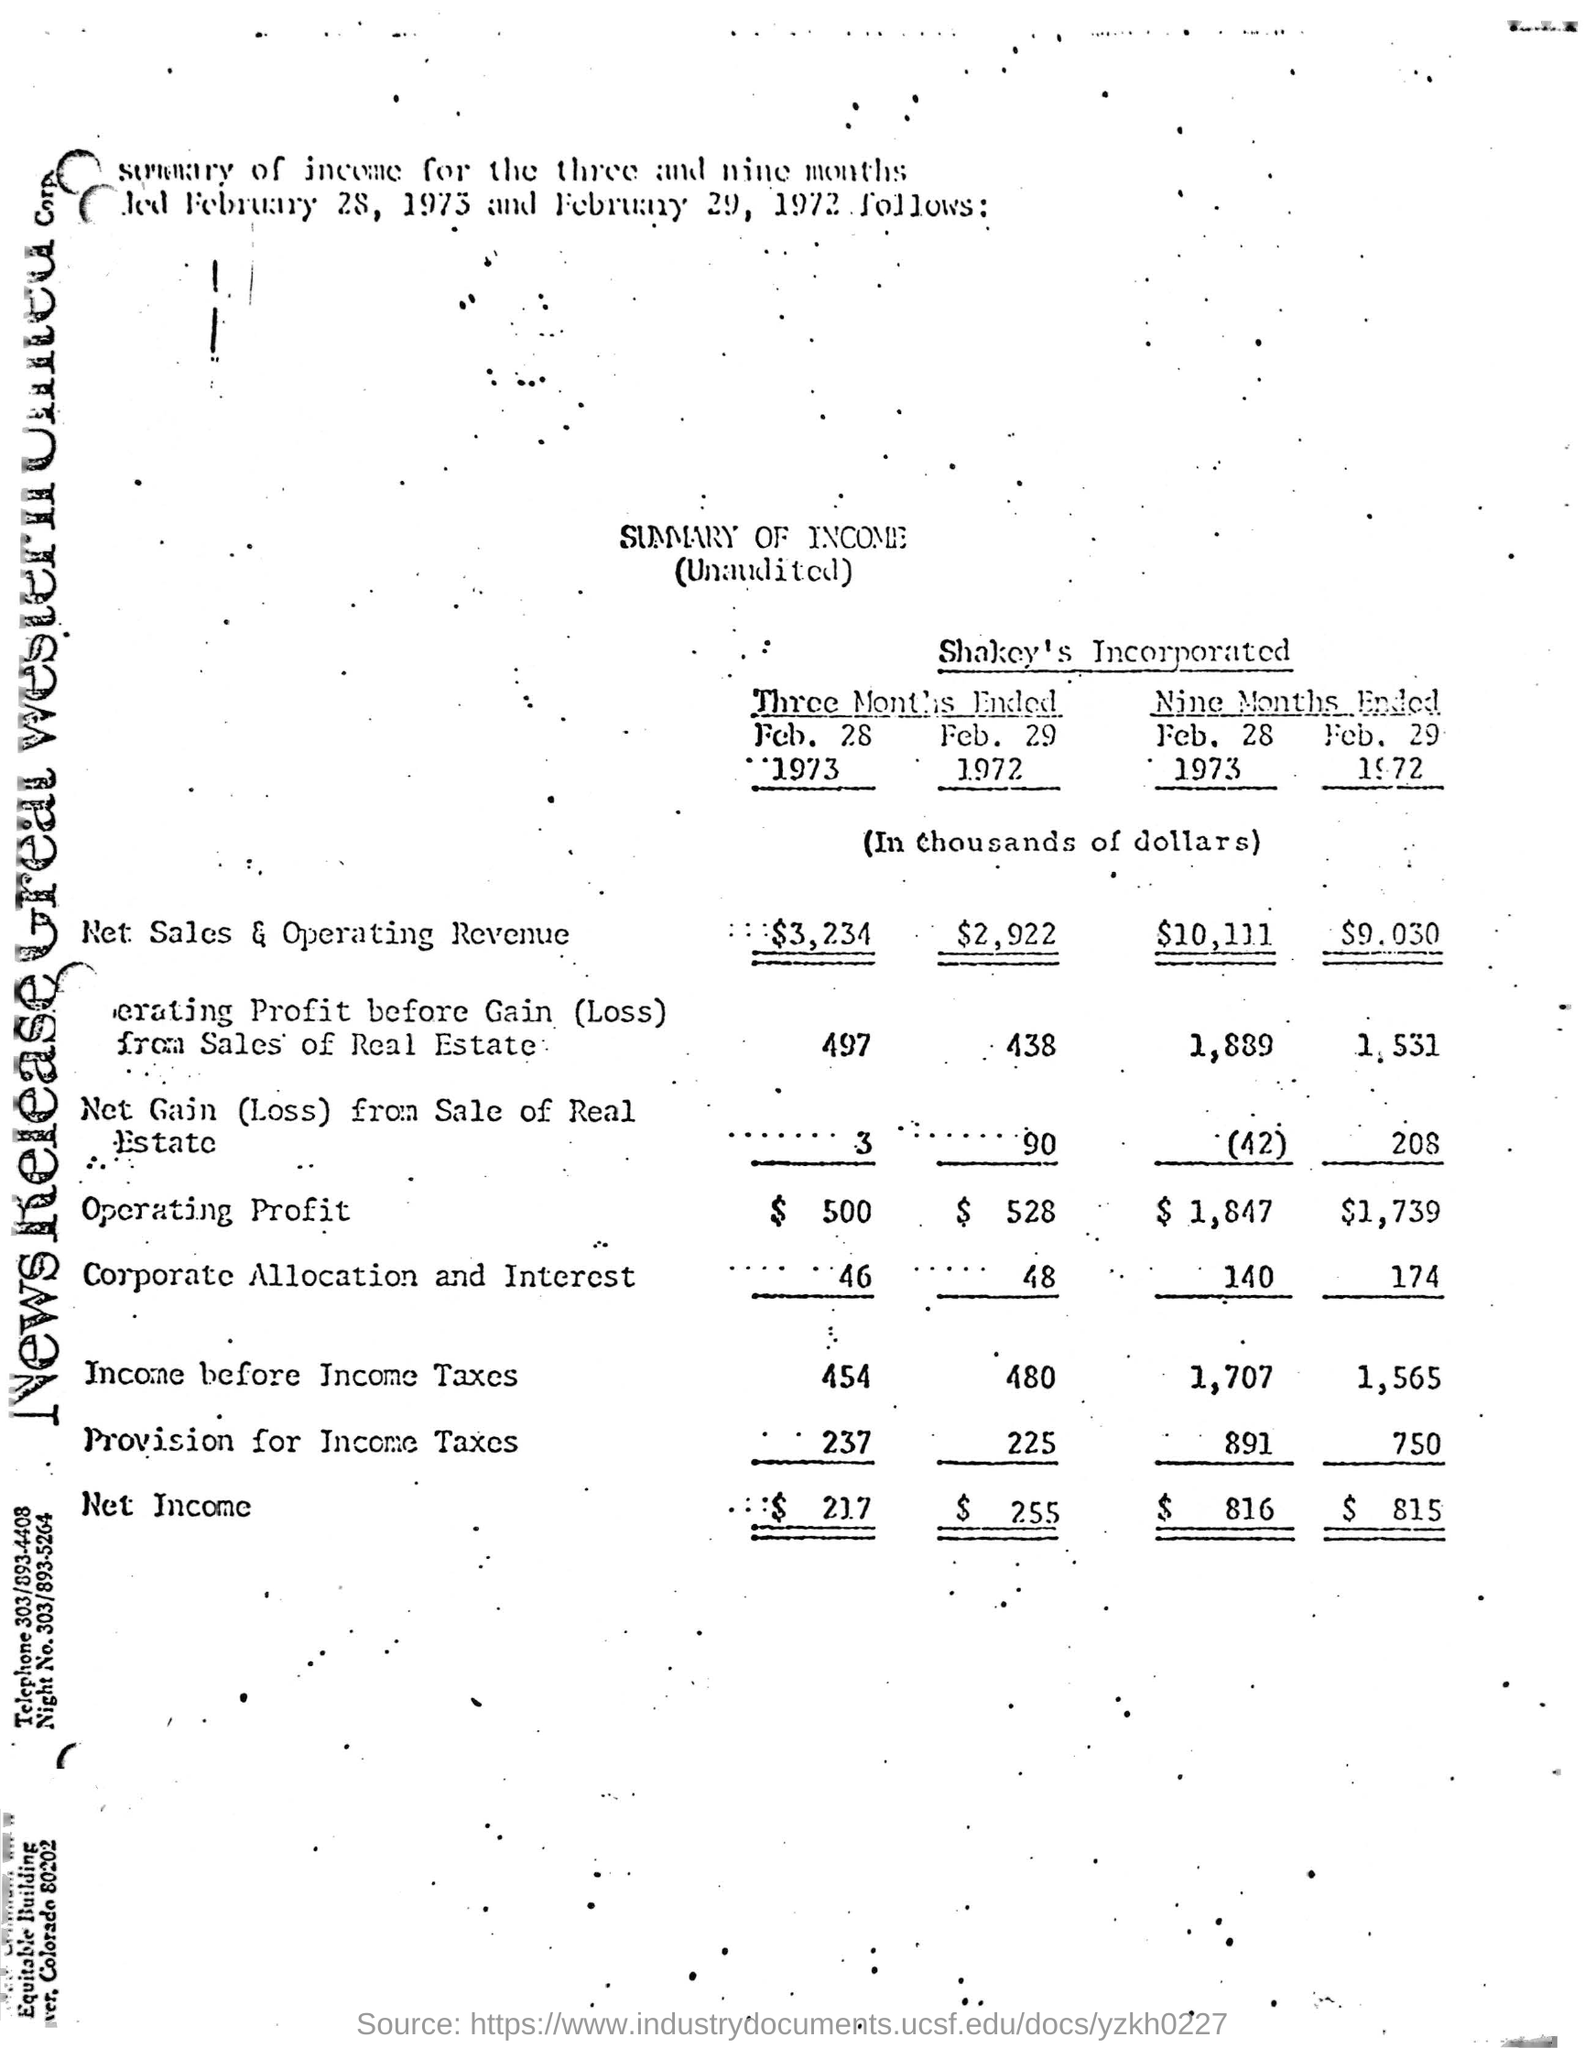Figures/Amounts were in which currency?
Ensure brevity in your answer.  Dollars,$. 